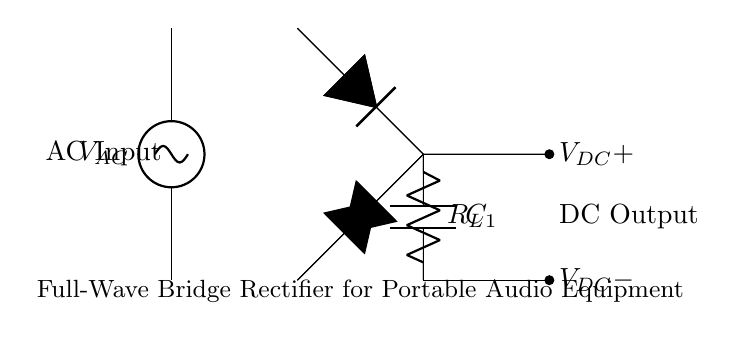What is the type of circuit shown? The circuit is a full-wave bridge rectifier, which is characterized by its use of four diodes arranged in a bridge configuration to convert AC voltage to DC voltage.
Answer: full-wave bridge rectifier How many diodes are used in this rectifier? The circuit clearly shows four diodes in the bridge configuration, which is standard for full-wave bridge rectifiers.
Answer: four What is the purpose of the capacitor in this circuit? The capacitor is used to smooth out the DC output, reducing voltage ripple by storing charge and releasing it when the voltage dips.
Answer: smoothing What are the labels for the DC output terminals? The DC output terminals are labeled as VDC+ for the positive terminal and VDC- for the negative terminal.
Answer: VDC+ and VDC- What kind of loads can this rectifier output voltage be used for? The rectified and smoothed DC output is suitable for powering audio equipment and other low-power electronic devices commonly used in theater productions.
Answer: audio equipment Explain how the current flows through the circuit. In a bridge rectifier, during each AC cycle, the current flows through two diodes at a time, which allows for both halves of the AC waveform to contribute to the DC output. This results in a continuous flow of current in one direction, thus achieving full-wave rectification.
Answer: continuous flow What does 'C1' represent in the diagram? 'C1' represents the smoothing capacitor that helps to reduce voltage fluctuations in the DC output, ensuring a more stable supply for the connected load.
Answer: smoothing capacitor 